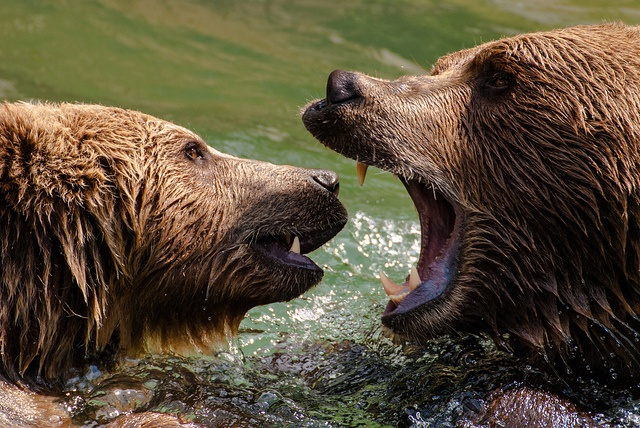Describe the objects in this image and their specific colors. I can see bear in olive, black, maroon, and gray tones and bear in olive, black, maroon, and gray tones in this image. 